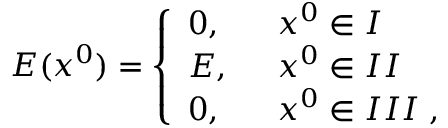<formula> <loc_0><loc_0><loc_500><loc_500>E ( x ^ { 0 } ) = \left \{ \begin{array} { l l } { 0 , \, } & { { x ^ { 0 } \in I } } \\ { E , \, } & { { x ^ { 0 } \in I I } } \\ { 0 , \, } & { { x ^ { 0 } \in I I I \, , } } \end{array}</formula> 